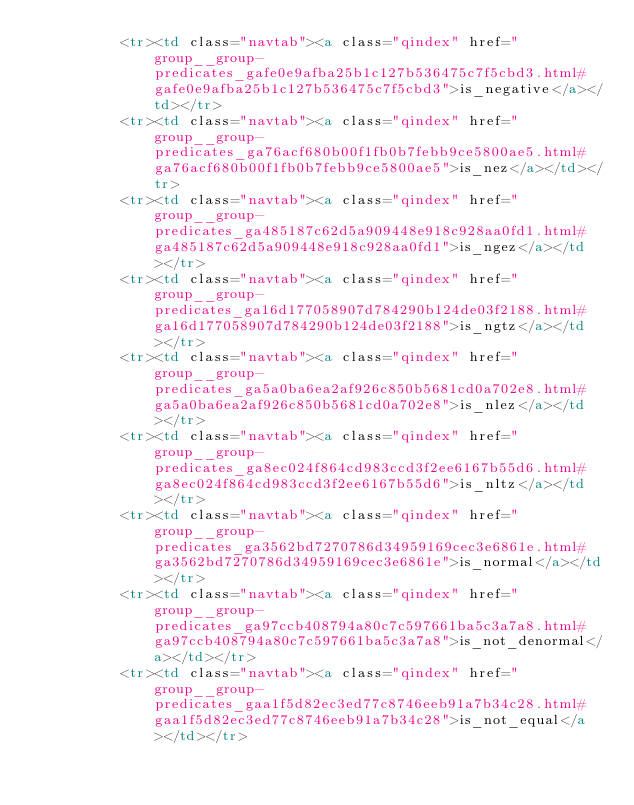Convert code to text. <code><loc_0><loc_0><loc_500><loc_500><_HTML_>          <tr><td class="navtab"><a class="qindex" href="group__group-predicates_gafe0e9afba25b1c127b536475c7f5cbd3.html#gafe0e9afba25b1c127b536475c7f5cbd3">is_negative</a></td></tr>
          <tr><td class="navtab"><a class="qindex" href="group__group-predicates_ga76acf680b00f1fb0b7febb9ce5800ae5.html#ga76acf680b00f1fb0b7febb9ce5800ae5">is_nez</a></td></tr>
          <tr><td class="navtab"><a class="qindex" href="group__group-predicates_ga485187c62d5a909448e918c928aa0fd1.html#ga485187c62d5a909448e918c928aa0fd1">is_ngez</a></td></tr>
          <tr><td class="navtab"><a class="qindex" href="group__group-predicates_ga16d177058907d784290b124de03f2188.html#ga16d177058907d784290b124de03f2188">is_ngtz</a></td></tr>
          <tr><td class="navtab"><a class="qindex" href="group__group-predicates_ga5a0ba6ea2af926c850b5681cd0a702e8.html#ga5a0ba6ea2af926c850b5681cd0a702e8">is_nlez</a></td></tr>
          <tr><td class="navtab"><a class="qindex" href="group__group-predicates_ga8ec024f864cd983ccd3f2ee6167b55d6.html#ga8ec024f864cd983ccd3f2ee6167b55d6">is_nltz</a></td></tr>
          <tr><td class="navtab"><a class="qindex" href="group__group-predicates_ga3562bd7270786d34959169cec3e6861e.html#ga3562bd7270786d34959169cec3e6861e">is_normal</a></td></tr>
          <tr><td class="navtab"><a class="qindex" href="group__group-predicates_ga97ccb408794a80c7c597661ba5c3a7a8.html#ga97ccb408794a80c7c597661ba5c3a7a8">is_not_denormal</a></td></tr>
          <tr><td class="navtab"><a class="qindex" href="group__group-predicates_gaa1f5d82ec3ed77c8746eeb91a7b34c28.html#gaa1f5d82ec3ed77c8746eeb91a7b34c28">is_not_equal</a></td></tr></code> 